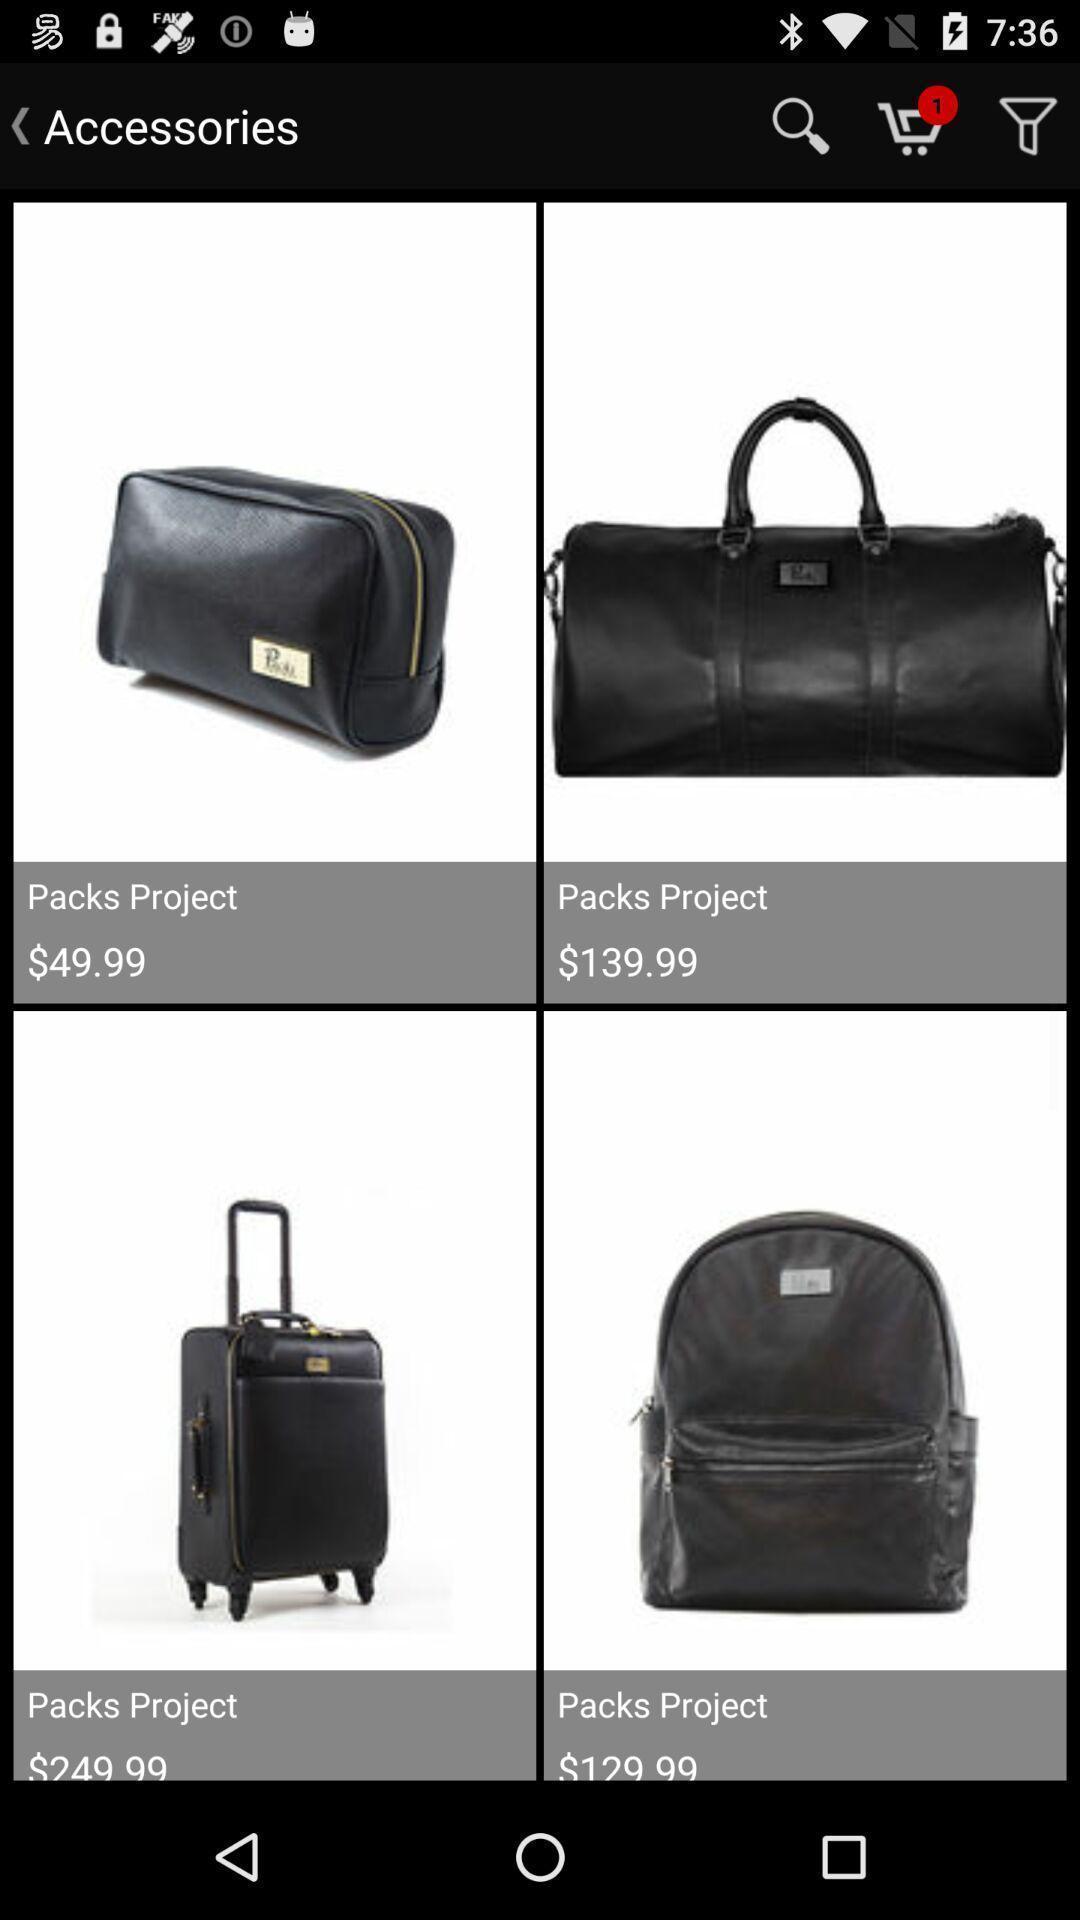Describe the visual elements of this screenshot. Shopping page contains bags for sale. 